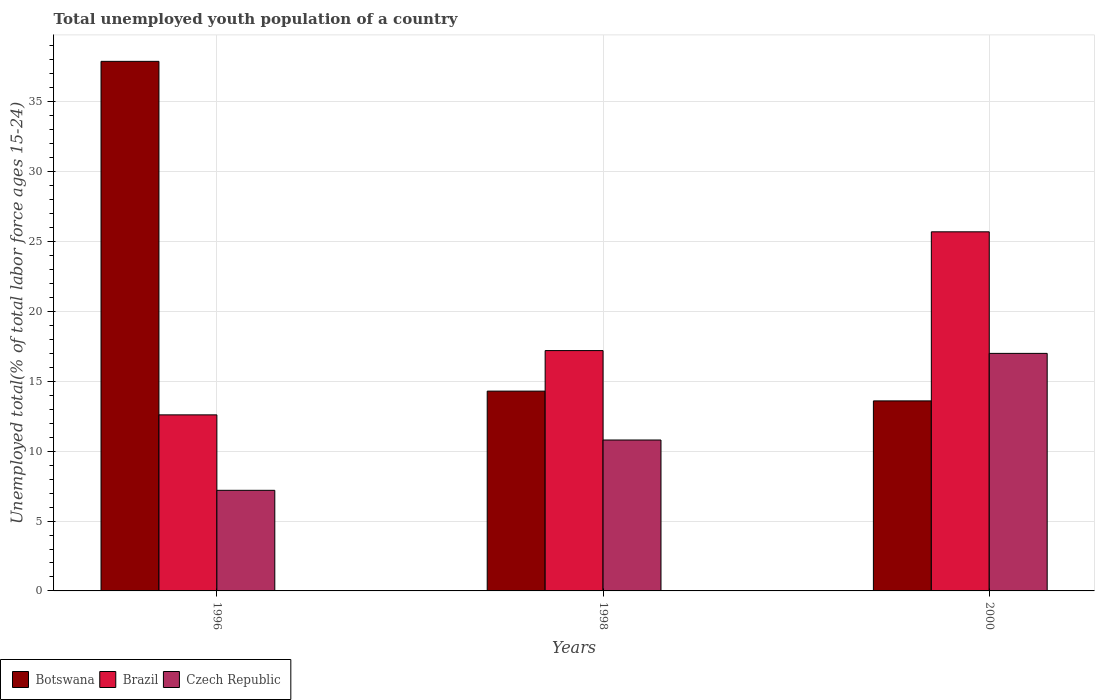How many bars are there on the 3rd tick from the left?
Your response must be concise. 3. How many bars are there on the 1st tick from the right?
Ensure brevity in your answer.  3. What is the percentage of total unemployed youth population of a country in Czech Republic in 2000?
Keep it short and to the point. 17. Across all years, what is the maximum percentage of total unemployed youth population of a country in Brazil?
Your answer should be compact. 25.7. Across all years, what is the minimum percentage of total unemployed youth population of a country in Brazil?
Make the answer very short. 12.6. In which year was the percentage of total unemployed youth population of a country in Czech Republic minimum?
Make the answer very short. 1996. What is the total percentage of total unemployed youth population of a country in Czech Republic in the graph?
Offer a terse response. 35. What is the difference between the percentage of total unemployed youth population of a country in Brazil in 1996 and that in 1998?
Ensure brevity in your answer.  -4.6. What is the difference between the percentage of total unemployed youth population of a country in Brazil in 2000 and the percentage of total unemployed youth population of a country in Botswana in 1998?
Your response must be concise. 11.4. What is the average percentage of total unemployed youth population of a country in Botswana per year?
Give a very brief answer. 21.93. In the year 1996, what is the difference between the percentage of total unemployed youth population of a country in Brazil and percentage of total unemployed youth population of a country in Botswana?
Keep it short and to the point. -25.3. In how many years, is the percentage of total unemployed youth population of a country in Brazil greater than 38 %?
Your answer should be compact. 0. What is the ratio of the percentage of total unemployed youth population of a country in Brazil in 1996 to that in 1998?
Offer a very short reply. 0.73. Is the difference between the percentage of total unemployed youth population of a country in Brazil in 1998 and 2000 greater than the difference between the percentage of total unemployed youth population of a country in Botswana in 1998 and 2000?
Offer a very short reply. No. What is the difference between the highest and the second highest percentage of total unemployed youth population of a country in Czech Republic?
Your answer should be compact. 6.2. What is the difference between the highest and the lowest percentage of total unemployed youth population of a country in Czech Republic?
Offer a terse response. 9.8. In how many years, is the percentage of total unemployed youth population of a country in Botswana greater than the average percentage of total unemployed youth population of a country in Botswana taken over all years?
Give a very brief answer. 1. What does the 1st bar from the left in 2000 represents?
Offer a terse response. Botswana. What does the 3rd bar from the right in 1996 represents?
Offer a terse response. Botswana. Is it the case that in every year, the sum of the percentage of total unemployed youth population of a country in Brazil and percentage of total unemployed youth population of a country in Czech Republic is greater than the percentage of total unemployed youth population of a country in Botswana?
Give a very brief answer. No. Are all the bars in the graph horizontal?
Keep it short and to the point. No. How many years are there in the graph?
Ensure brevity in your answer.  3. Does the graph contain grids?
Offer a terse response. Yes. Where does the legend appear in the graph?
Your answer should be compact. Bottom left. What is the title of the graph?
Provide a short and direct response. Total unemployed youth population of a country. Does "Tanzania" appear as one of the legend labels in the graph?
Provide a short and direct response. No. What is the label or title of the X-axis?
Make the answer very short. Years. What is the label or title of the Y-axis?
Offer a very short reply. Unemployed total(% of total labor force ages 15-24). What is the Unemployed total(% of total labor force ages 15-24) of Botswana in 1996?
Keep it short and to the point. 37.9. What is the Unemployed total(% of total labor force ages 15-24) of Brazil in 1996?
Make the answer very short. 12.6. What is the Unemployed total(% of total labor force ages 15-24) in Czech Republic in 1996?
Your answer should be compact. 7.2. What is the Unemployed total(% of total labor force ages 15-24) in Botswana in 1998?
Make the answer very short. 14.3. What is the Unemployed total(% of total labor force ages 15-24) in Brazil in 1998?
Provide a short and direct response. 17.2. What is the Unemployed total(% of total labor force ages 15-24) in Czech Republic in 1998?
Offer a very short reply. 10.8. What is the Unemployed total(% of total labor force ages 15-24) of Botswana in 2000?
Keep it short and to the point. 13.6. What is the Unemployed total(% of total labor force ages 15-24) of Brazil in 2000?
Keep it short and to the point. 25.7. What is the Unemployed total(% of total labor force ages 15-24) of Czech Republic in 2000?
Give a very brief answer. 17. Across all years, what is the maximum Unemployed total(% of total labor force ages 15-24) in Botswana?
Provide a succinct answer. 37.9. Across all years, what is the maximum Unemployed total(% of total labor force ages 15-24) of Brazil?
Make the answer very short. 25.7. Across all years, what is the minimum Unemployed total(% of total labor force ages 15-24) of Botswana?
Ensure brevity in your answer.  13.6. Across all years, what is the minimum Unemployed total(% of total labor force ages 15-24) of Brazil?
Keep it short and to the point. 12.6. Across all years, what is the minimum Unemployed total(% of total labor force ages 15-24) in Czech Republic?
Keep it short and to the point. 7.2. What is the total Unemployed total(% of total labor force ages 15-24) of Botswana in the graph?
Keep it short and to the point. 65.8. What is the total Unemployed total(% of total labor force ages 15-24) of Brazil in the graph?
Offer a terse response. 55.5. What is the total Unemployed total(% of total labor force ages 15-24) in Czech Republic in the graph?
Give a very brief answer. 35. What is the difference between the Unemployed total(% of total labor force ages 15-24) in Botswana in 1996 and that in 1998?
Make the answer very short. 23.6. What is the difference between the Unemployed total(% of total labor force ages 15-24) of Brazil in 1996 and that in 1998?
Offer a terse response. -4.6. What is the difference between the Unemployed total(% of total labor force ages 15-24) of Czech Republic in 1996 and that in 1998?
Provide a short and direct response. -3.6. What is the difference between the Unemployed total(% of total labor force ages 15-24) of Botswana in 1996 and that in 2000?
Give a very brief answer. 24.3. What is the difference between the Unemployed total(% of total labor force ages 15-24) in Czech Republic in 1996 and that in 2000?
Provide a short and direct response. -9.8. What is the difference between the Unemployed total(% of total labor force ages 15-24) of Botswana in 1998 and that in 2000?
Keep it short and to the point. 0.7. What is the difference between the Unemployed total(% of total labor force ages 15-24) in Botswana in 1996 and the Unemployed total(% of total labor force ages 15-24) in Brazil in 1998?
Your answer should be compact. 20.7. What is the difference between the Unemployed total(% of total labor force ages 15-24) in Botswana in 1996 and the Unemployed total(% of total labor force ages 15-24) in Czech Republic in 1998?
Your answer should be very brief. 27.1. What is the difference between the Unemployed total(% of total labor force ages 15-24) of Brazil in 1996 and the Unemployed total(% of total labor force ages 15-24) of Czech Republic in 1998?
Give a very brief answer. 1.8. What is the difference between the Unemployed total(% of total labor force ages 15-24) in Botswana in 1996 and the Unemployed total(% of total labor force ages 15-24) in Brazil in 2000?
Provide a succinct answer. 12.2. What is the difference between the Unemployed total(% of total labor force ages 15-24) of Botswana in 1996 and the Unemployed total(% of total labor force ages 15-24) of Czech Republic in 2000?
Offer a terse response. 20.9. What is the average Unemployed total(% of total labor force ages 15-24) in Botswana per year?
Ensure brevity in your answer.  21.93. What is the average Unemployed total(% of total labor force ages 15-24) of Czech Republic per year?
Provide a short and direct response. 11.67. In the year 1996, what is the difference between the Unemployed total(% of total labor force ages 15-24) in Botswana and Unemployed total(% of total labor force ages 15-24) in Brazil?
Offer a very short reply. 25.3. In the year 1996, what is the difference between the Unemployed total(% of total labor force ages 15-24) in Botswana and Unemployed total(% of total labor force ages 15-24) in Czech Republic?
Ensure brevity in your answer.  30.7. In the year 1996, what is the difference between the Unemployed total(% of total labor force ages 15-24) in Brazil and Unemployed total(% of total labor force ages 15-24) in Czech Republic?
Your answer should be compact. 5.4. In the year 1998, what is the difference between the Unemployed total(% of total labor force ages 15-24) of Botswana and Unemployed total(% of total labor force ages 15-24) of Brazil?
Your answer should be very brief. -2.9. In the year 1998, what is the difference between the Unemployed total(% of total labor force ages 15-24) of Botswana and Unemployed total(% of total labor force ages 15-24) of Czech Republic?
Give a very brief answer. 3.5. In the year 2000, what is the difference between the Unemployed total(% of total labor force ages 15-24) in Botswana and Unemployed total(% of total labor force ages 15-24) in Brazil?
Your answer should be very brief. -12.1. In the year 2000, what is the difference between the Unemployed total(% of total labor force ages 15-24) of Botswana and Unemployed total(% of total labor force ages 15-24) of Czech Republic?
Provide a succinct answer. -3.4. In the year 2000, what is the difference between the Unemployed total(% of total labor force ages 15-24) in Brazil and Unemployed total(% of total labor force ages 15-24) in Czech Republic?
Make the answer very short. 8.7. What is the ratio of the Unemployed total(% of total labor force ages 15-24) of Botswana in 1996 to that in 1998?
Make the answer very short. 2.65. What is the ratio of the Unemployed total(% of total labor force ages 15-24) in Brazil in 1996 to that in 1998?
Your answer should be very brief. 0.73. What is the ratio of the Unemployed total(% of total labor force ages 15-24) in Czech Republic in 1996 to that in 1998?
Ensure brevity in your answer.  0.67. What is the ratio of the Unemployed total(% of total labor force ages 15-24) in Botswana in 1996 to that in 2000?
Your response must be concise. 2.79. What is the ratio of the Unemployed total(% of total labor force ages 15-24) of Brazil in 1996 to that in 2000?
Your answer should be compact. 0.49. What is the ratio of the Unemployed total(% of total labor force ages 15-24) in Czech Republic in 1996 to that in 2000?
Offer a very short reply. 0.42. What is the ratio of the Unemployed total(% of total labor force ages 15-24) of Botswana in 1998 to that in 2000?
Ensure brevity in your answer.  1.05. What is the ratio of the Unemployed total(% of total labor force ages 15-24) of Brazil in 1998 to that in 2000?
Give a very brief answer. 0.67. What is the ratio of the Unemployed total(% of total labor force ages 15-24) of Czech Republic in 1998 to that in 2000?
Offer a very short reply. 0.64. What is the difference between the highest and the second highest Unemployed total(% of total labor force ages 15-24) in Botswana?
Your answer should be very brief. 23.6. What is the difference between the highest and the second highest Unemployed total(% of total labor force ages 15-24) in Czech Republic?
Make the answer very short. 6.2. What is the difference between the highest and the lowest Unemployed total(% of total labor force ages 15-24) of Botswana?
Your answer should be very brief. 24.3. 